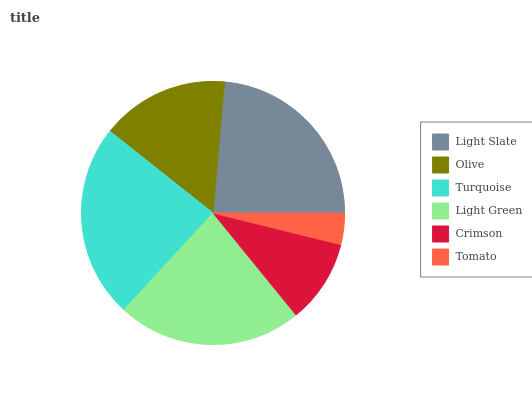Is Tomato the minimum?
Answer yes or no. Yes. Is Turquoise the maximum?
Answer yes or no. Yes. Is Olive the minimum?
Answer yes or no. No. Is Olive the maximum?
Answer yes or no. No. Is Light Slate greater than Olive?
Answer yes or no. Yes. Is Olive less than Light Slate?
Answer yes or no. Yes. Is Olive greater than Light Slate?
Answer yes or no. No. Is Light Slate less than Olive?
Answer yes or no. No. Is Light Green the high median?
Answer yes or no. Yes. Is Olive the low median?
Answer yes or no. Yes. Is Tomato the high median?
Answer yes or no. No. Is Crimson the low median?
Answer yes or no. No. 